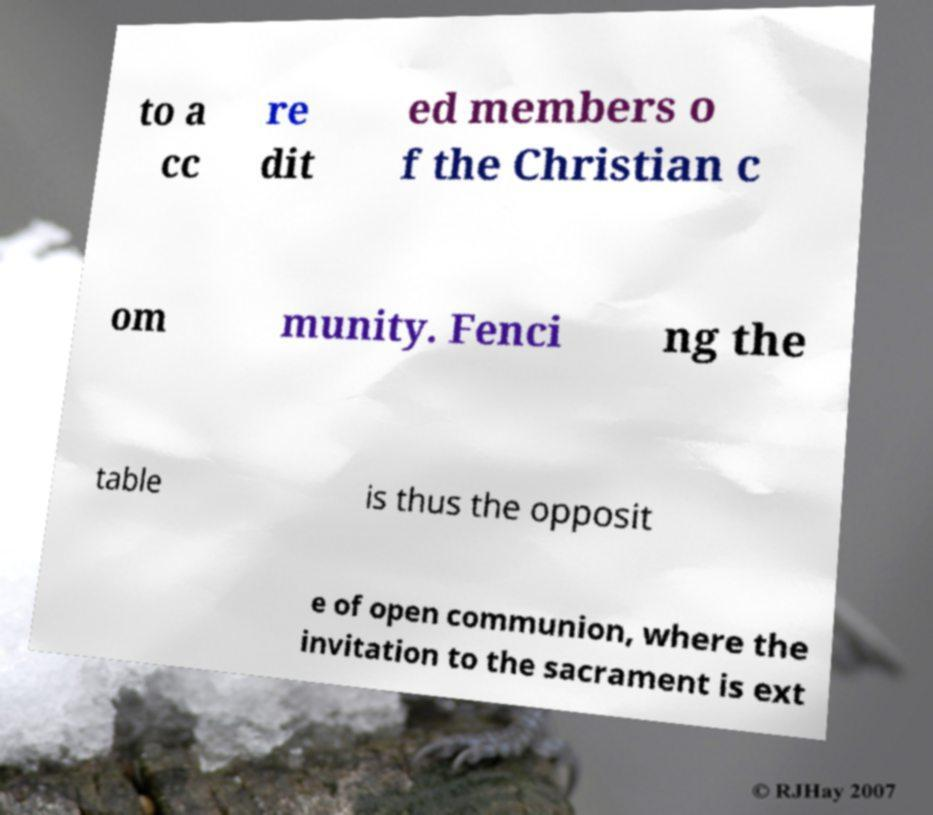Please identify and transcribe the text found in this image. to a cc re dit ed members o f the Christian c om munity. Fenci ng the table is thus the opposit e of open communion, where the invitation to the sacrament is ext 